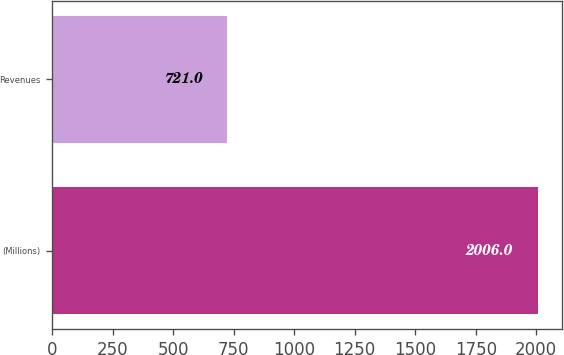<chart> <loc_0><loc_0><loc_500><loc_500><bar_chart><fcel>(Millions)<fcel>Revenues<nl><fcel>2006<fcel>721<nl></chart> 